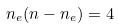<formula> <loc_0><loc_0><loc_500><loc_500>n _ { e } ( n - n _ { e } ) = 4</formula> 